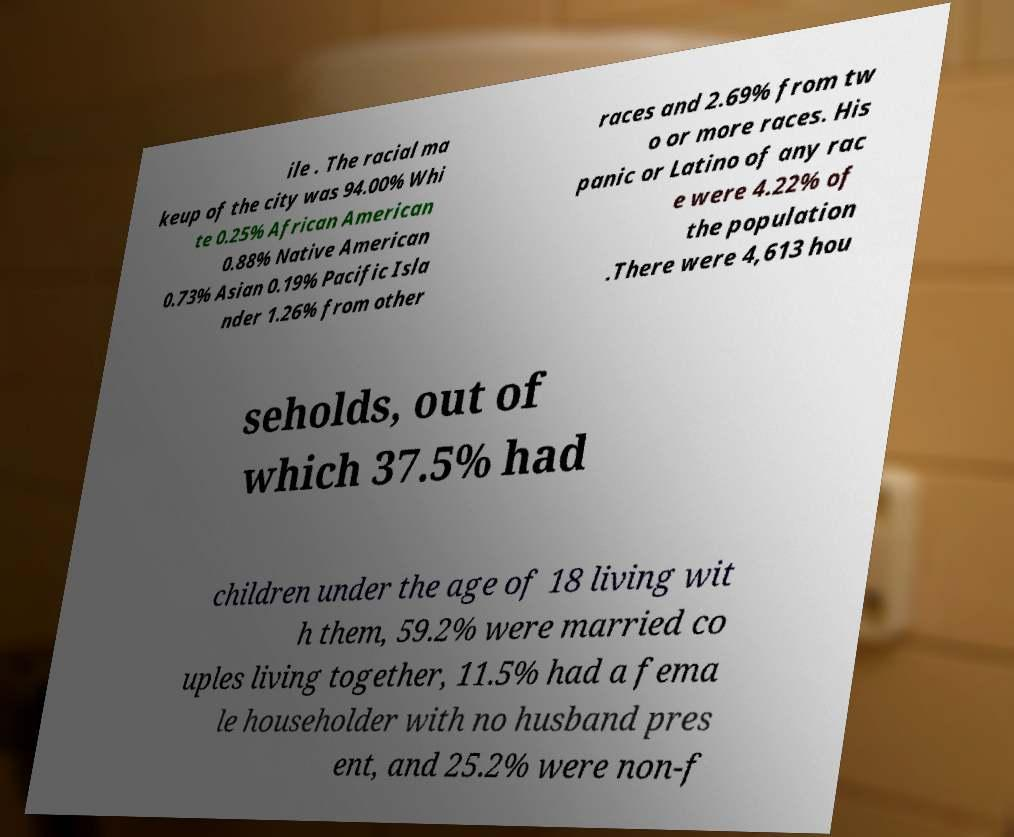Can you accurately transcribe the text from the provided image for me? ile . The racial ma keup of the city was 94.00% Whi te 0.25% African American 0.88% Native American 0.73% Asian 0.19% Pacific Isla nder 1.26% from other races and 2.69% from tw o or more races. His panic or Latino of any rac e were 4.22% of the population .There were 4,613 hou seholds, out of which 37.5% had children under the age of 18 living wit h them, 59.2% were married co uples living together, 11.5% had a fema le householder with no husband pres ent, and 25.2% were non-f 